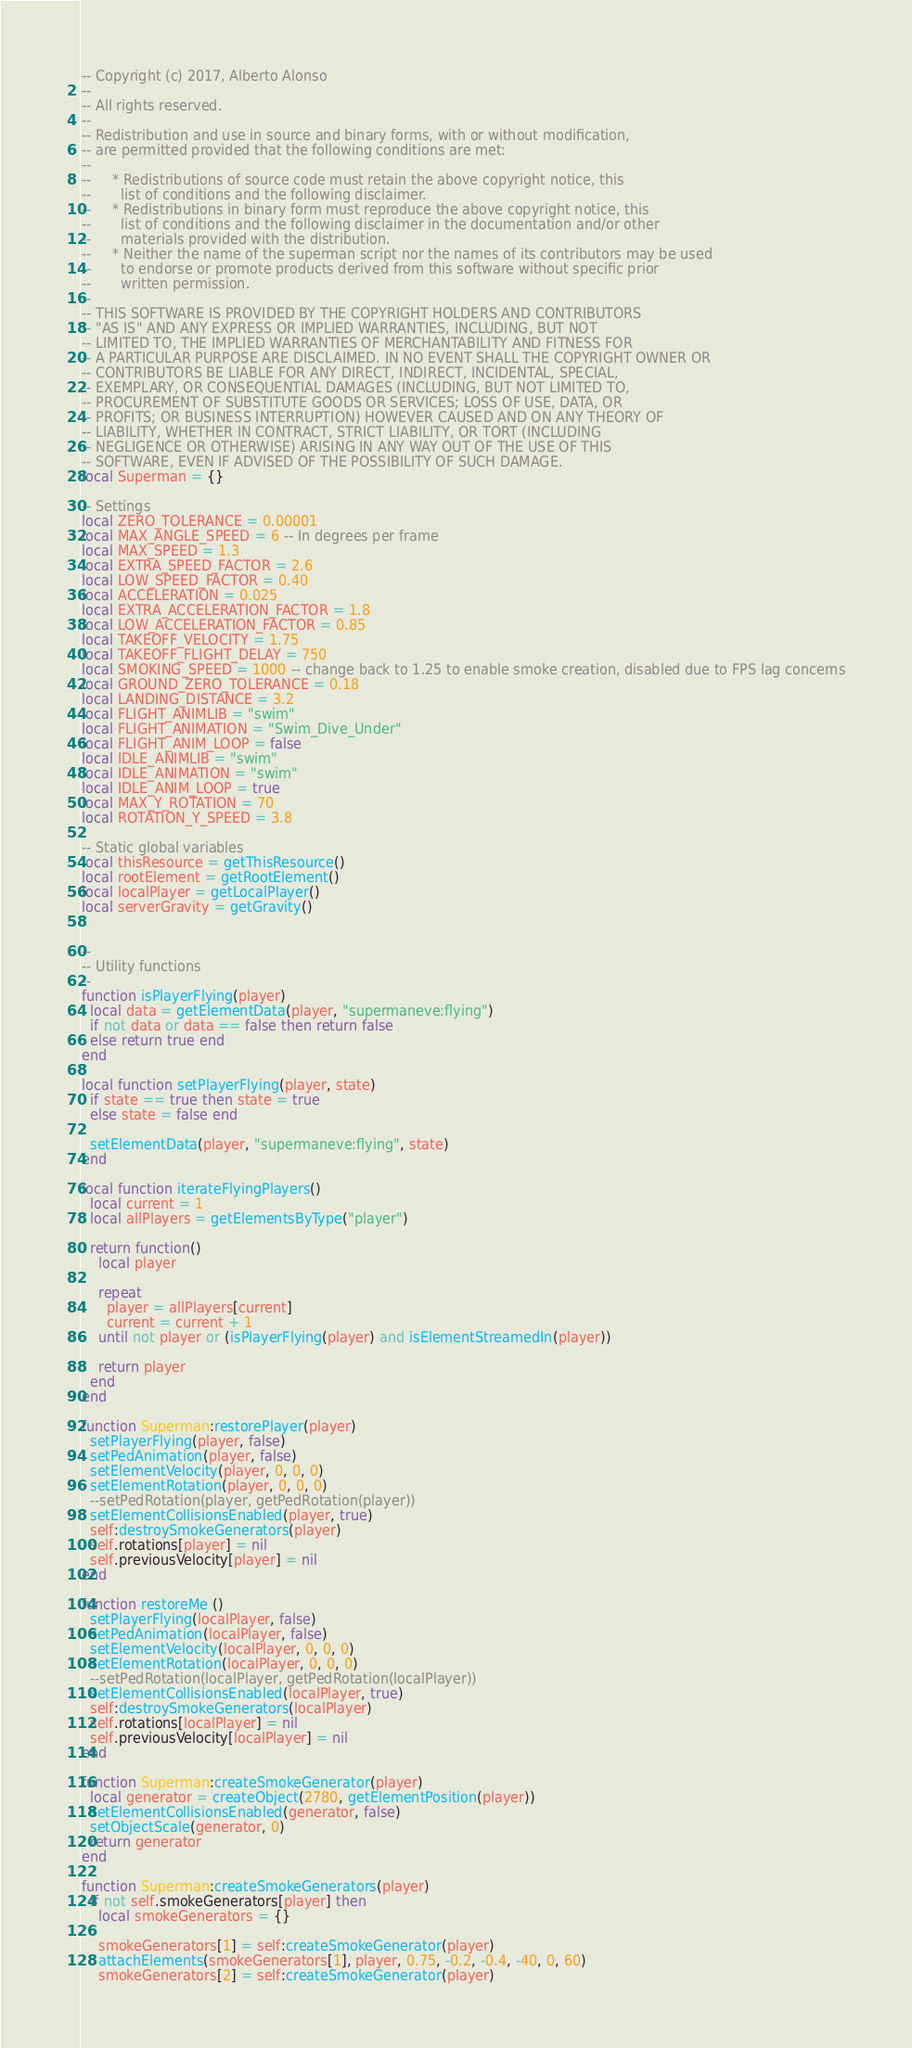<code> <loc_0><loc_0><loc_500><loc_500><_Lua_>-- Copyright (c) 2017, Alberto Alonso
--
-- All rights reserved.
--
-- Redistribution and use in source and binary forms, with or without modification,
-- are permitted provided that the following conditions are met:
--
--     * Redistributions of source code must retain the above copyright notice, this
--       list of conditions and the following disclaimer.
--     * Redistributions in binary form must reproduce the above copyright notice, this
--       list of conditions and the following disclaimer in the documentation and/or other
--       materials provided with the distribution.
--     * Neither the name of the superman script nor the names of its contributors may be used
--       to endorse or promote products derived from this software without specific prior
--       written permission.
--
-- THIS SOFTWARE IS PROVIDED BY THE COPYRIGHT HOLDERS AND CONTRIBUTORS
-- "AS IS" AND ANY EXPRESS OR IMPLIED WARRANTIES, INCLUDING, BUT NOT
-- LIMITED TO, THE IMPLIED WARRANTIES OF MERCHANTABILITY AND FITNESS FOR
-- A PARTICULAR PURPOSE ARE DISCLAIMED. IN NO EVENT SHALL THE COPYRIGHT OWNER OR
-- CONTRIBUTORS BE LIABLE FOR ANY DIRECT, INDIRECT, INCIDENTAL, SPECIAL,
-- EXEMPLARY, OR CONSEQUENTIAL DAMAGES (INCLUDING, BUT NOT LIMITED TO,
-- PROCUREMENT OF SUBSTITUTE GOODS OR SERVICES; LOSS OF USE, DATA, OR
-- PROFITS; OR BUSINESS INTERRUPTION) HOWEVER CAUSED AND ON ANY THEORY OF
-- LIABILITY, WHETHER IN CONTRACT, STRICT LIABILITY, OR TORT (INCLUDING
-- NEGLIGENCE OR OTHERWISE) ARISING IN ANY WAY OUT OF THE USE OF THIS
-- SOFTWARE, EVEN IF ADVISED OF THE POSSIBILITY OF SUCH DAMAGE.
local Superman = {}

-- Settings
local ZERO_TOLERANCE = 0.00001
local MAX_ANGLE_SPEED = 6 -- In degrees per frame
local MAX_SPEED = 1.3
local EXTRA_SPEED_FACTOR = 2.6
local LOW_SPEED_FACTOR = 0.40
local ACCELERATION = 0.025
local EXTRA_ACCELERATION_FACTOR = 1.8
local LOW_ACCELERATION_FACTOR = 0.85
local TAKEOFF_VELOCITY = 1.75
local TAKEOFF_FLIGHT_DELAY = 750
local SMOKING_SPEED = 1000 -- change back to 1.25 to enable smoke creation, disabled due to FPS lag concerns
local GROUND_ZERO_TOLERANCE = 0.18
local LANDING_DISTANCE = 3.2
local FLIGHT_ANIMLIB = "swim"
local FLIGHT_ANIMATION = "Swim_Dive_Under"
local FLIGHT_ANIM_LOOP = false
local IDLE_ANIMLIB = "swim"
local IDLE_ANIMATION = "swim"
local IDLE_ANIM_LOOP = true
local MAX_Y_ROTATION = 70
local ROTATION_Y_SPEED = 3.8

-- Static global variables
local thisResource = getThisResource()
local rootElement = getRootElement()
local localPlayer = getLocalPlayer()
local serverGravity = getGravity()


--
-- Utility functions
--
function isPlayerFlying(player)
  local data = getElementData(player, "supermaneve:flying")
  if not data or data == false then return false
  else return true end
end

local function setPlayerFlying(player, state)
  if state == true then state = true
  else state = false end

  setElementData(player, "supermaneve:flying", state)
end

local function iterateFlyingPlayers()
  local current = 1
  local allPlayers = getElementsByType("player")

  return function()
    local player

    repeat
      player = allPlayers[current]
      current = current + 1
    until not player or (isPlayerFlying(player) and isElementStreamedIn(player))

    return player
  end
end

function Superman:restorePlayer(player)
  setPlayerFlying(player, false)
  setPedAnimation(player, false)
  setElementVelocity(player, 0, 0, 0)
  setElementRotation(player, 0, 0, 0)
  --setPedRotation(player, getPedRotation(player))
  setElementCollisionsEnabled(player, true)
  self:destroySmokeGenerators(player)
  self.rotations[player] = nil
  self.previousVelocity[player] = nil
end

function restoreMe ()
  setPlayerFlying(localPlayer, false)
  setPedAnimation(localPlayer, false)
  setElementVelocity(localPlayer, 0, 0, 0)
  setElementRotation(localPlayer, 0, 0, 0)
  --setPedRotation(localPlayer, getPedRotation(localPlayer))
  setElementCollisionsEnabled(localPlayer, true)
  self:destroySmokeGenerators(localPlayer)
  self.rotations[localPlayer] = nil
  self.previousVelocity[localPlayer] = nil
end

function Superman:createSmokeGenerator(player)
  local generator = createObject(2780, getElementPosition(player))
  setElementCollisionsEnabled(generator, false)
  setObjectScale(generator, 0)
  return generator
end

function Superman:createSmokeGenerators(player)
  if not self.smokeGenerators[player] then
    local smokeGenerators = {}

    smokeGenerators[1] = self:createSmokeGenerator(player)
    attachElements(smokeGenerators[1], player, 0.75, -0.2, -0.4, -40, 0, 60)
    smokeGenerators[2] = self:createSmokeGenerator(player)</code> 